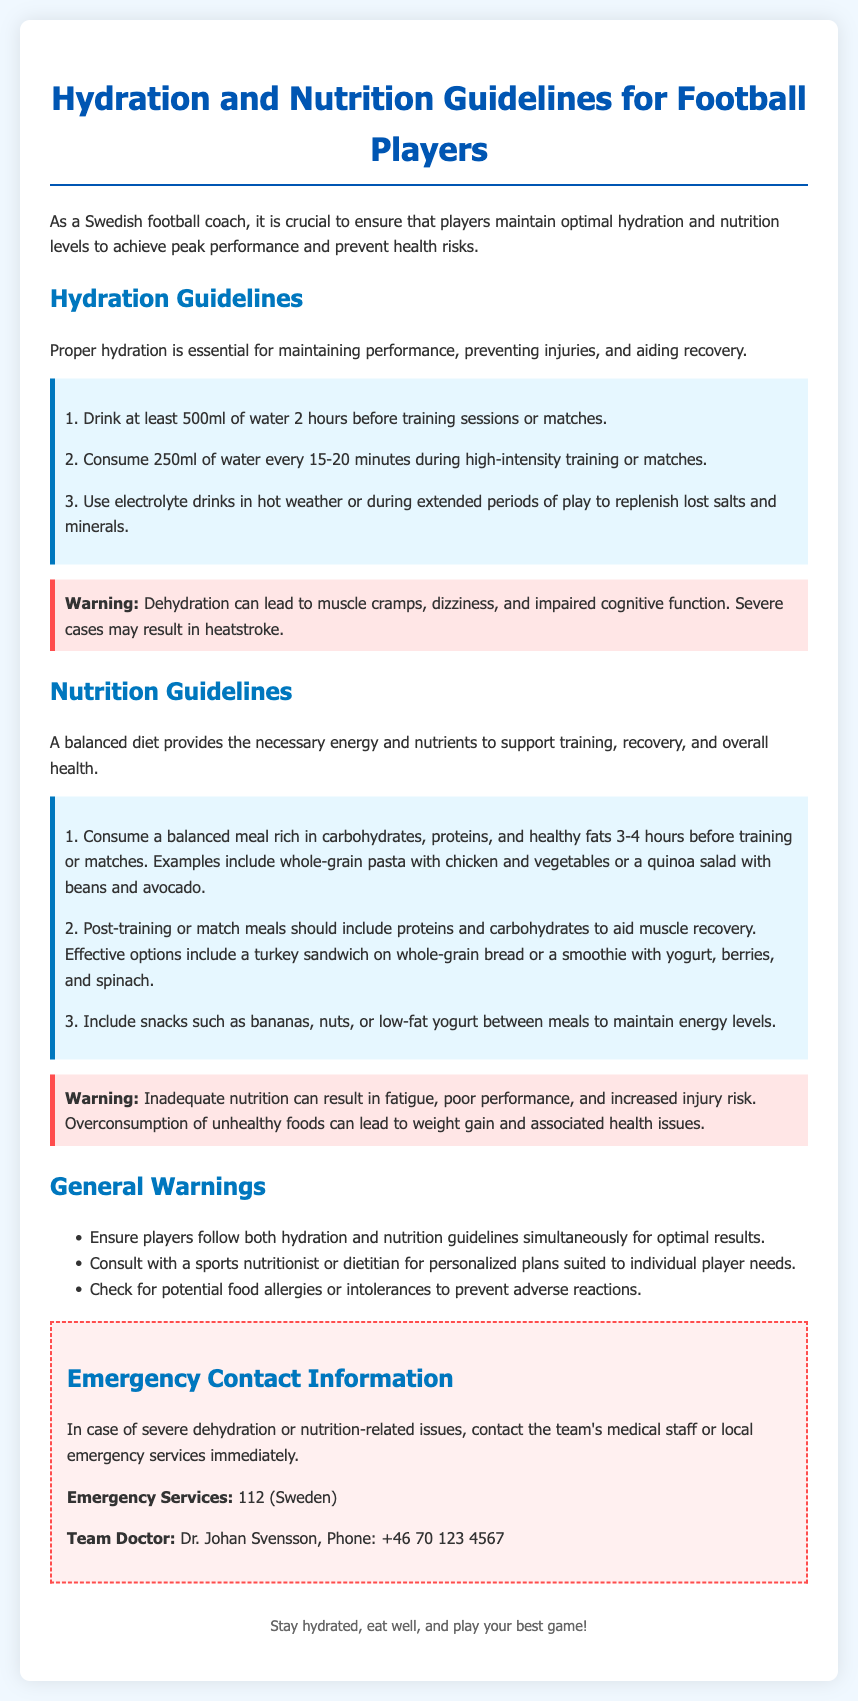What is the hydration guideline for water consumption before training? The document states that players should drink at least 500ml of water 2 hours before training sessions or matches.
Answer: 500ml How often should players drink water during high-intensity training? It is recommended that players consume 250ml of water every 15-20 minutes during high-intensity training or matches.
Answer: 250ml every 15-20 minutes What are the consequences of dehydration mentioned in the warning? The warning highlights that dehydration can lead to muscle cramps, dizziness, impaired cognitive function, and severe cases may result in heatstroke.
Answer: Muscle cramps, dizziness, impaired cognitive function, heatstroke What type of meal should be consumed before training? Players should consume a balanced meal rich in carbohydrates, proteins, and healthy fats 3-4 hours before training or matches.
Answer: Balanced meal rich in carbohydrates, proteins, and healthy fats What should post-training meals include to aid recovery? Post-training or match meals should include proteins and carbohydrates to aid muscle recovery.
Answer: Proteins and carbohydrates What is the emergency contact number for severe dehydration in Sweden? The document provides the emergency contact number for severe dehydration in Sweden as 112.
Answer: 112 How many general warnings are listed in the document? The document lists three general warnings that players should follow.
Answer: Three What is the recommended snack to maintain energy levels? Players can include snacks such as bananas, nuts, or low-fat yogurt between meals to maintain energy levels.
Answer: Bananas, nuts, low-fat yogurt 